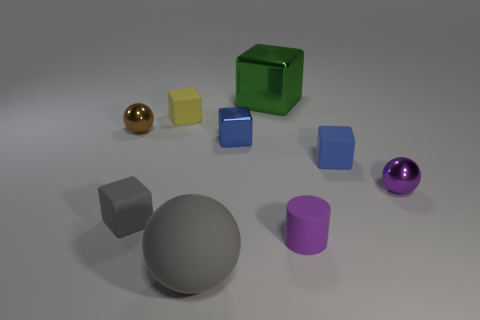Subtract all blue blocks. How many blocks are left? 3 Subtract all green blocks. How many blocks are left? 4 Subtract all yellow cubes. Subtract all red cylinders. How many cubes are left? 4 Subtract all cylinders. How many objects are left? 8 Add 4 gray matte objects. How many gray matte objects exist? 6 Subtract 0 cyan cylinders. How many objects are left? 9 Subtract all big green cubes. Subtract all green metal blocks. How many objects are left? 7 Add 7 purple cylinders. How many purple cylinders are left? 8 